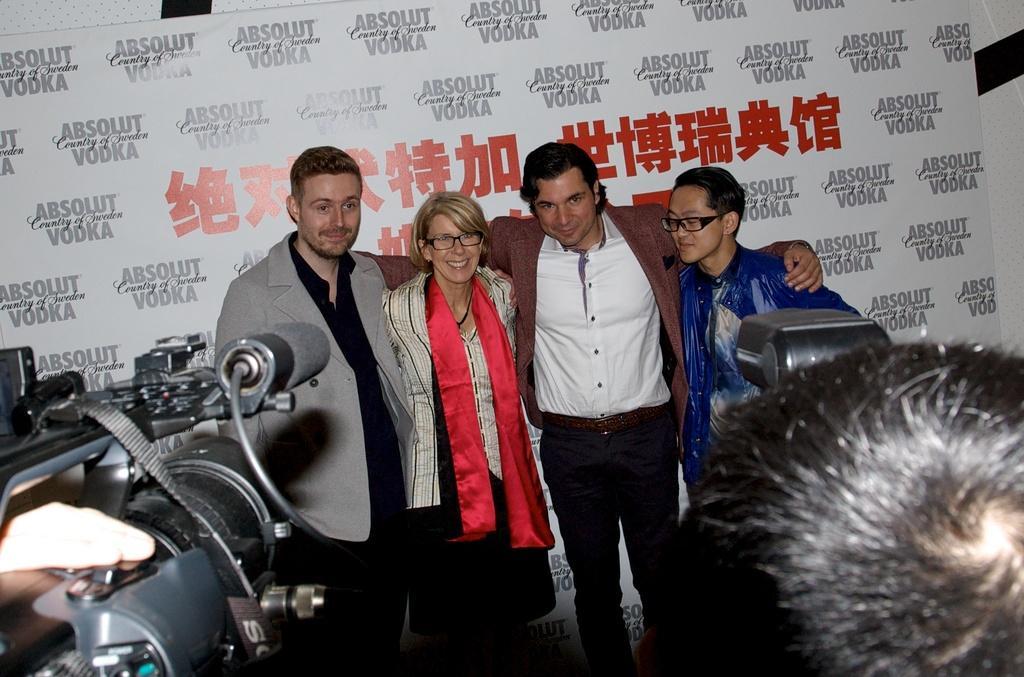How would you summarize this image in a sentence or two? In this image we can see a person´s hand on a camera on the left side and on the right side we can see a person´is head and an object. In the background we can see few persons and a hoarding. 